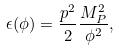Convert formula to latex. <formula><loc_0><loc_0><loc_500><loc_500>\epsilon ( \phi ) = \frac { p ^ { 2 } } { 2 } \frac { M _ { P } ^ { 2 } } { \phi ^ { 2 } } ,</formula> 